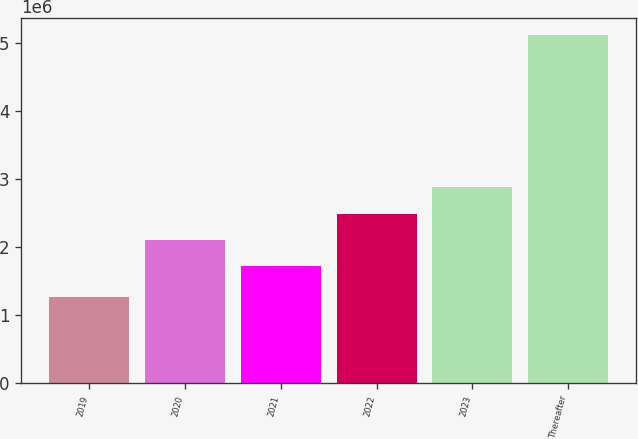Convert chart. <chart><loc_0><loc_0><loc_500><loc_500><bar_chart><fcel>2019<fcel>2020<fcel>2021<fcel>2022<fcel>2023<fcel>Thereafter<nl><fcel>1.27273e+06<fcel>2.09955e+06<fcel>1.71611e+06<fcel>2.483e+06<fcel>2.88488e+06<fcel>5.10718e+06<nl></chart> 